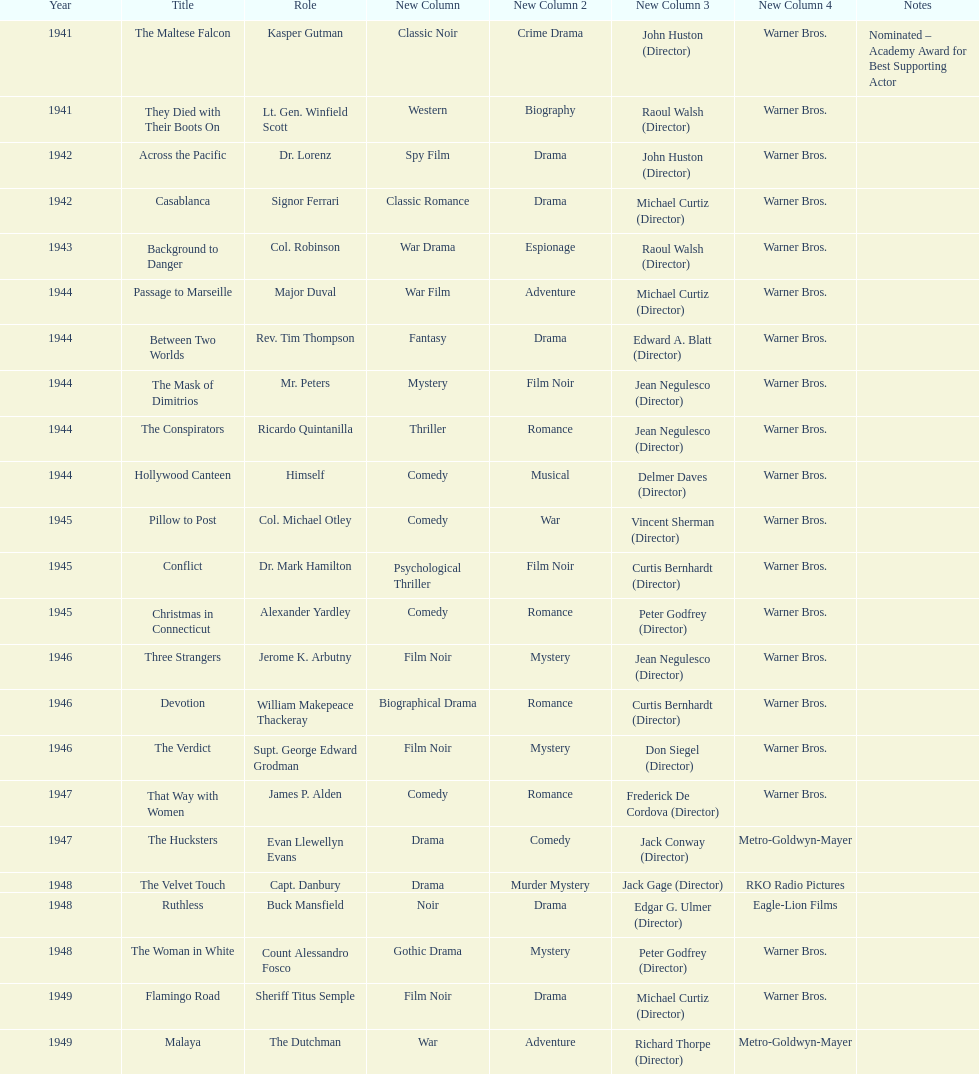How long did sydney greenstreet's acting career last? 9 years. 